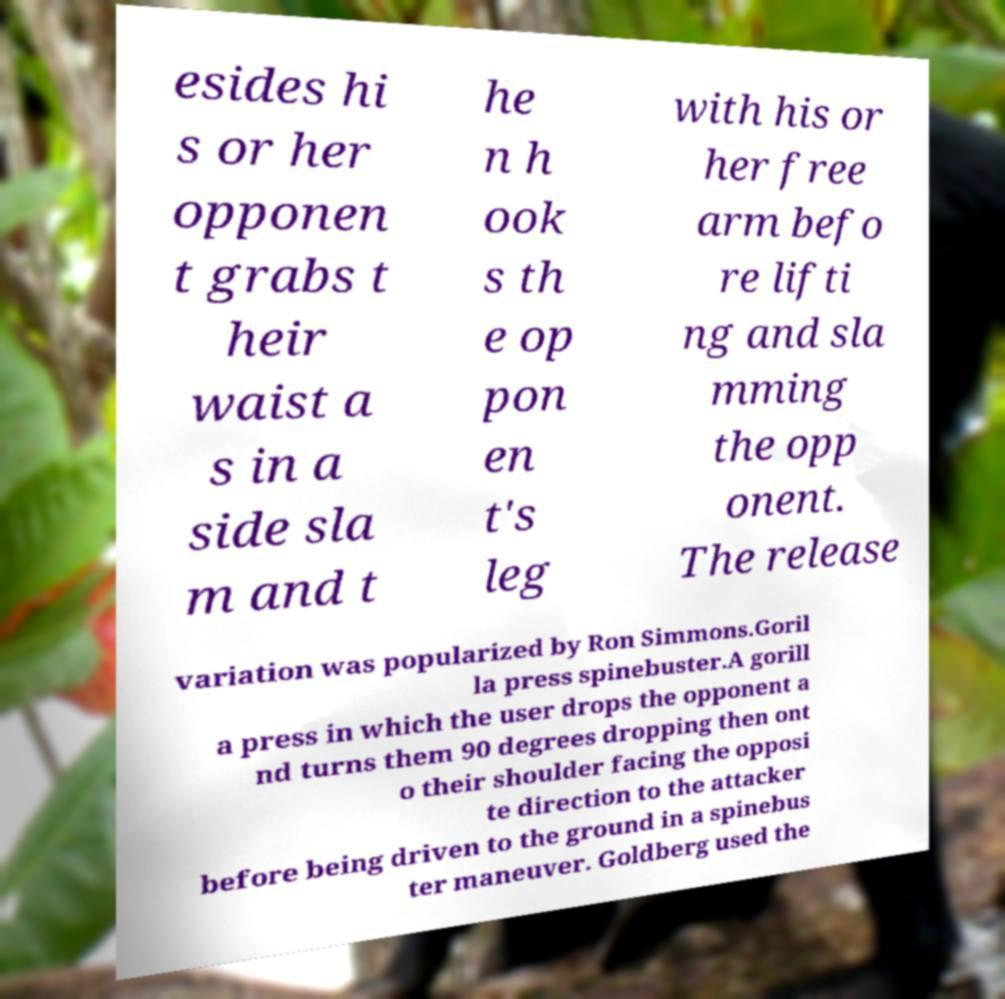For documentation purposes, I need the text within this image transcribed. Could you provide that? esides hi s or her opponen t grabs t heir waist a s in a side sla m and t he n h ook s th e op pon en t's leg with his or her free arm befo re lifti ng and sla mming the opp onent. The release variation was popularized by Ron Simmons.Goril la press spinebuster.A gorill a press in which the user drops the opponent a nd turns them 90 degrees dropping then ont o their shoulder facing the opposi te direction to the attacker before being driven to the ground in a spinebus ter maneuver. Goldberg used the 